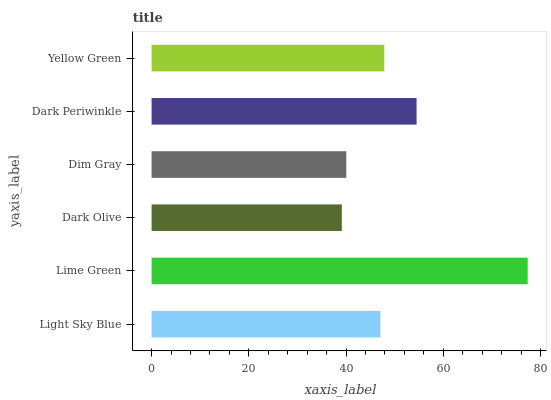Is Dark Olive the minimum?
Answer yes or no. Yes. Is Lime Green the maximum?
Answer yes or no. Yes. Is Lime Green the minimum?
Answer yes or no. No. Is Dark Olive the maximum?
Answer yes or no. No. Is Lime Green greater than Dark Olive?
Answer yes or no. Yes. Is Dark Olive less than Lime Green?
Answer yes or no. Yes. Is Dark Olive greater than Lime Green?
Answer yes or no. No. Is Lime Green less than Dark Olive?
Answer yes or no. No. Is Yellow Green the high median?
Answer yes or no. Yes. Is Light Sky Blue the low median?
Answer yes or no. Yes. Is Dark Olive the high median?
Answer yes or no. No. Is Dark Olive the low median?
Answer yes or no. No. 